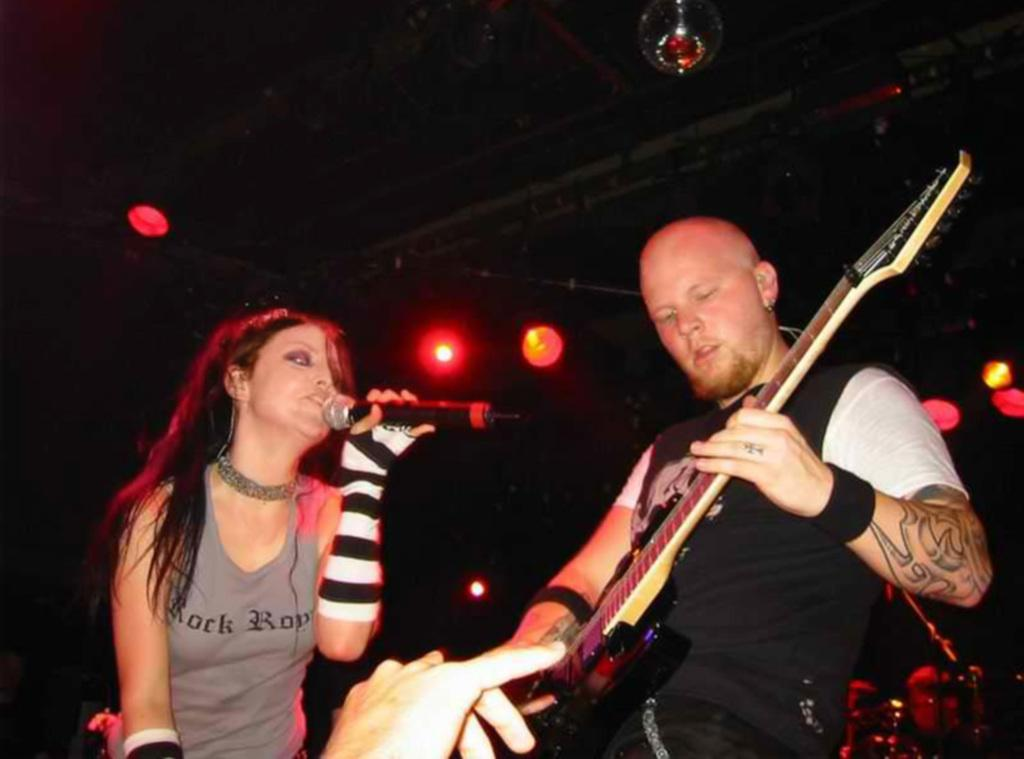How many people are in the image? There are two persons standing in the image. What are the people doing in the image? One person is holding a microphone and singing, while the other person is holding a guitar. What can be seen in the background of the image? There are focusing lights in the background of the image. What is the purpose of the toe in the image? There is no toe present in the image. Is there a church visible in the image? There is no church visible in the image. 